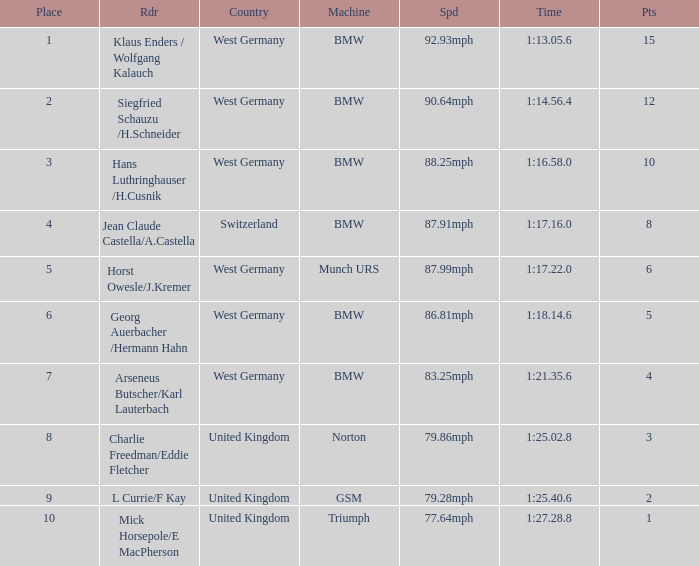Which places have points larger than 10? None. 